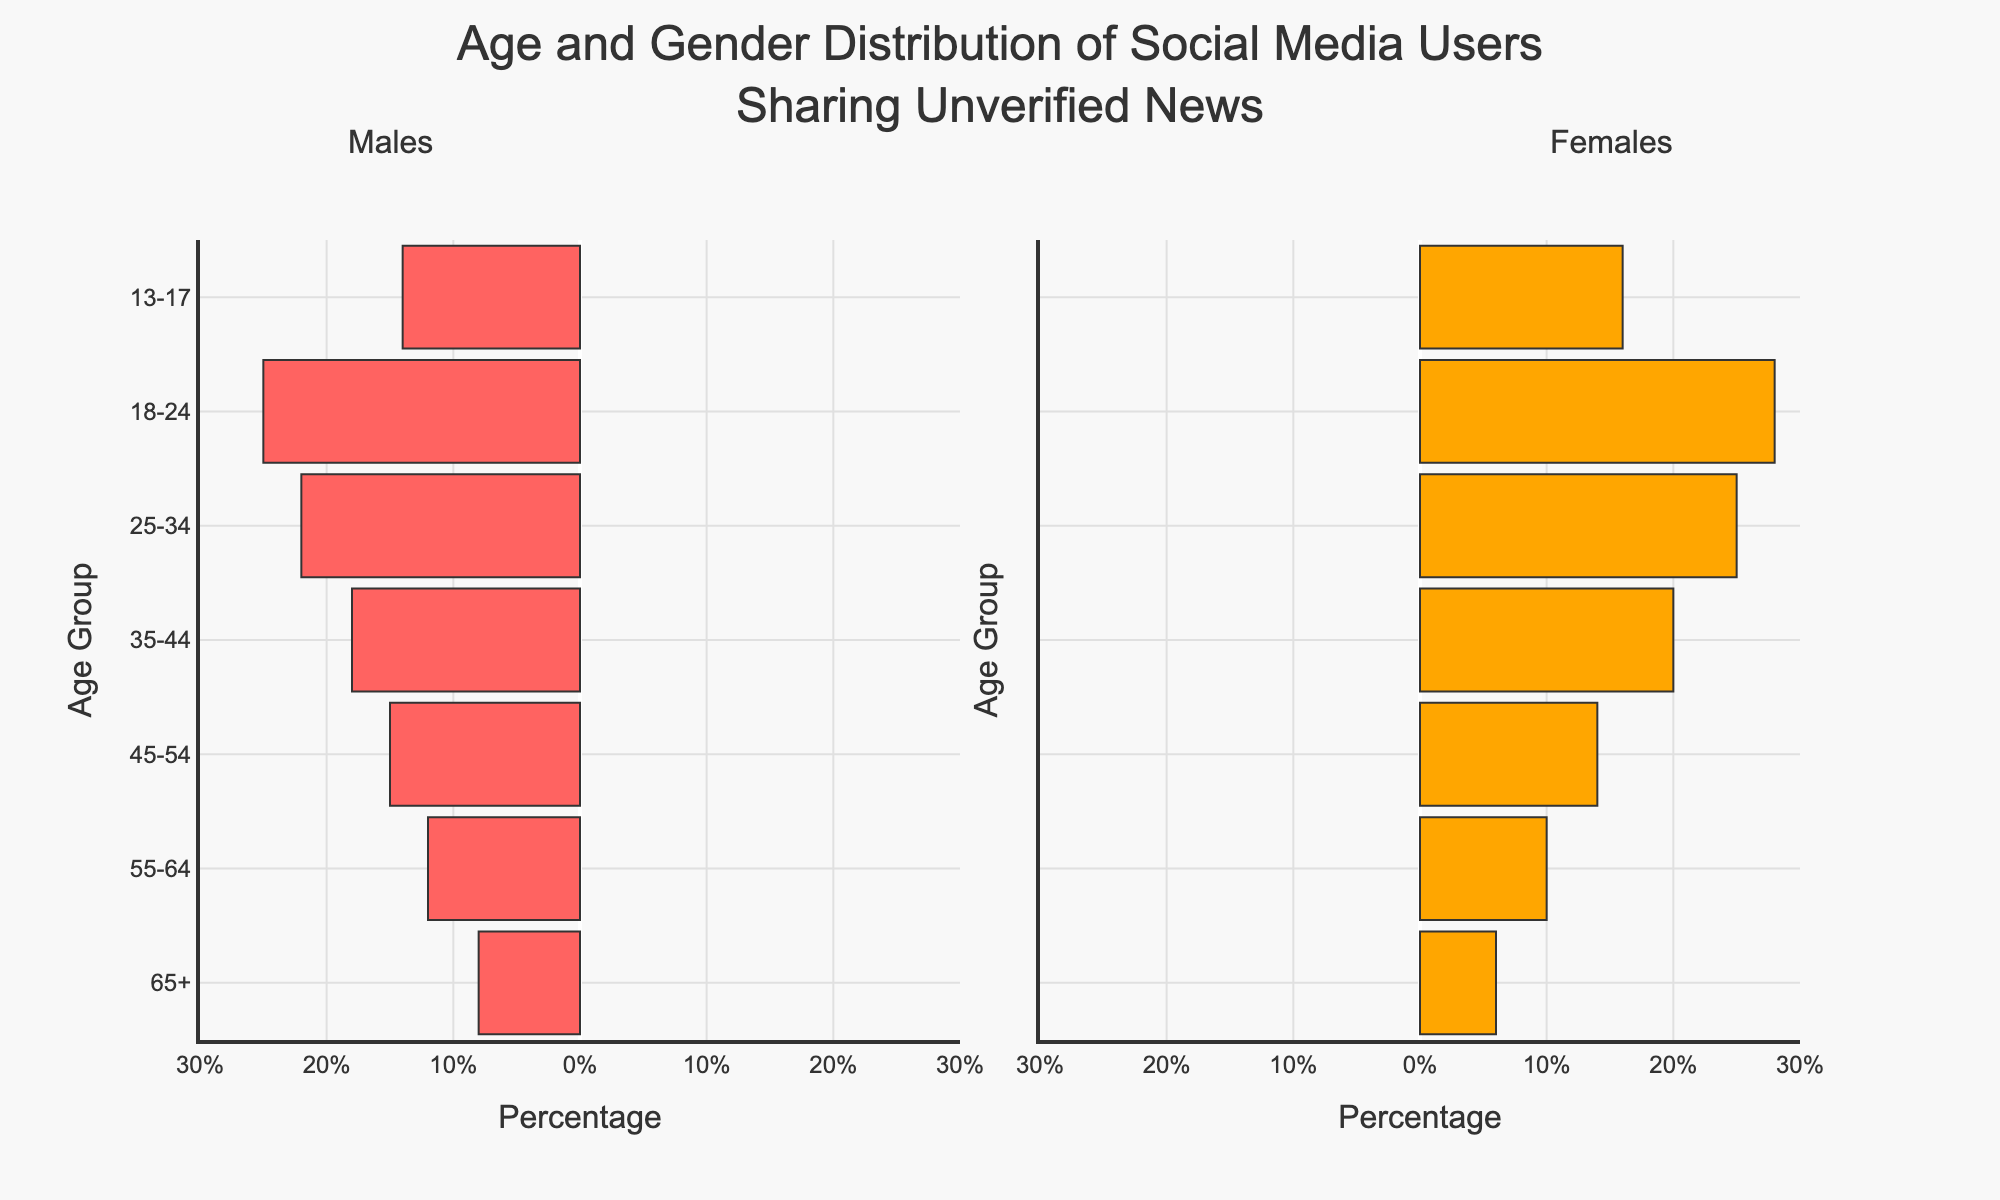Which age group of females has the highest percentage of users sharing unverified news? The "18-24" age group has the highest percentage of female users sharing unverified news at 28%.
Answer: 18-24 What is the total percentage of males in the 55-64 and 65+ age groups who share unverified news? The percentage of males in the 55-64 age group is 12%, and in the 65+ age group is 8%. Adding these together gives 12% + 8% = 20%.
Answer: 20% Which gender has a higher percentage of users in the 35-44 age group sharing unverified news? In the 35-44 age group, males have 18%, and females have 20%. Therefore, females have a higher percentage.
Answer: Females How does the percentage of males in the 18-24 age group compare to the percentage in the 25-34 age group for sharing unverified news? The percentage of males in the 18-24 age group is 25%, while in the 25-34 age group it is 22%. So, the percentage in the 18-24 age group is higher.
Answer: Higher in 18-24 What is the average percentage of females across all age groups who share unverified news? The percentages for females in each age group are 6%, 10%, 14%, 20%, 25%, 28%, and 16%. The average is calculated as (6 + 10 + 14 + 20 + 25 + 28 + 16) / 7 = 17%.
Answer: 17% Among males and females aged 13-17, which gender shares a higher percentage of unverified news? In the 13-17 age group, males share unverified news at a percentage of 14%, and females at 16%. Therefore, females share a higher percentage.
Answer: Females What is the combined percentage of males and females in the 45-54 age group sharing unverified news? The percentage of males in the 45-54 age group is 15%, and for females, it is 14%. Their combined percentage is 15% + 14% = 29%.
Answer: 29% Which age group has the lowest total percentage of users sharing unverified news, and what is the percentage? The "65+" age group has the lowest total percentage of users sharing unverified news, with males at 8% and females at 6%. The combined total is 8% + 6% = 14%.
Answer: 65+, 14% Is the percentage of males in any age group greater than 25%? No age group has a percentage of males sharing unverified news greater than 25%. The highest percentage is 25% in the 18-24 age group, which is equal to 25%.
Answer: No What is the percentage difference between males and females in the 25-34 age group who share unverified news? The percentage of males is 22%, and females is 25%. The difference is 25% - 22% = 3%.
Answer: 3% 